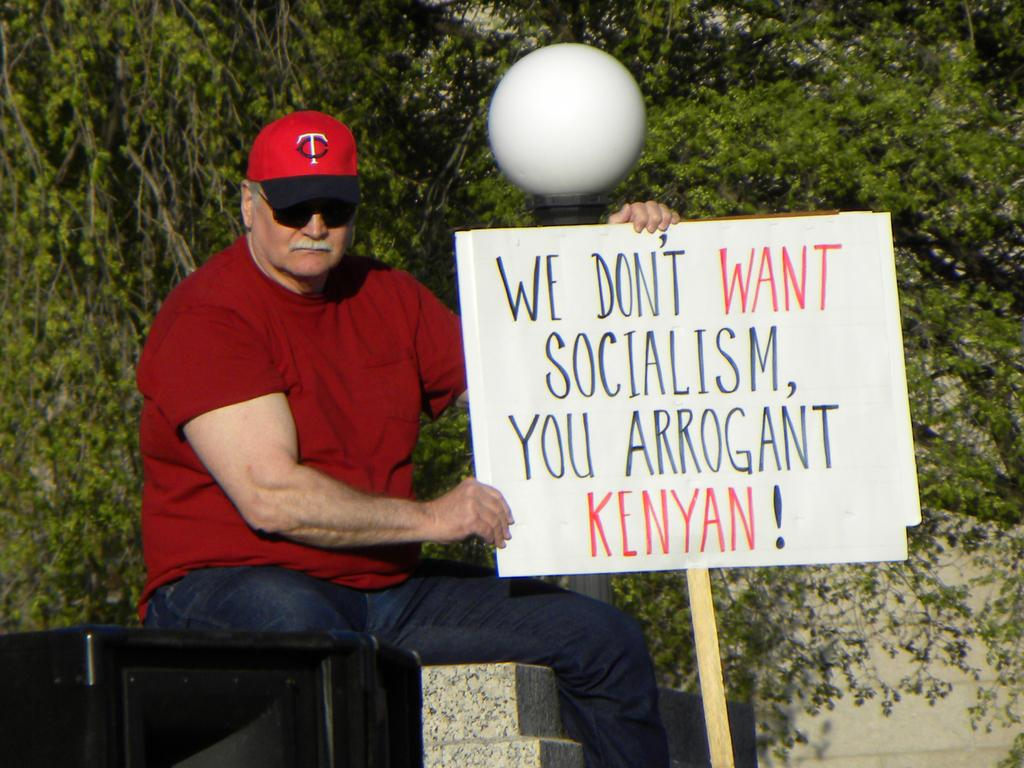What is the man in the image wearing? The man is wearing a red t-shirt. What is the man doing in the image? The man is sitting and holding a board with a stick. What can be seen in the background of the image? There is a light, a wall, and trees in the background of the image. What type of insurance does the man have for his chalk in the image? There is no chalk present in the image, and therefore no insurance can be discussed. 